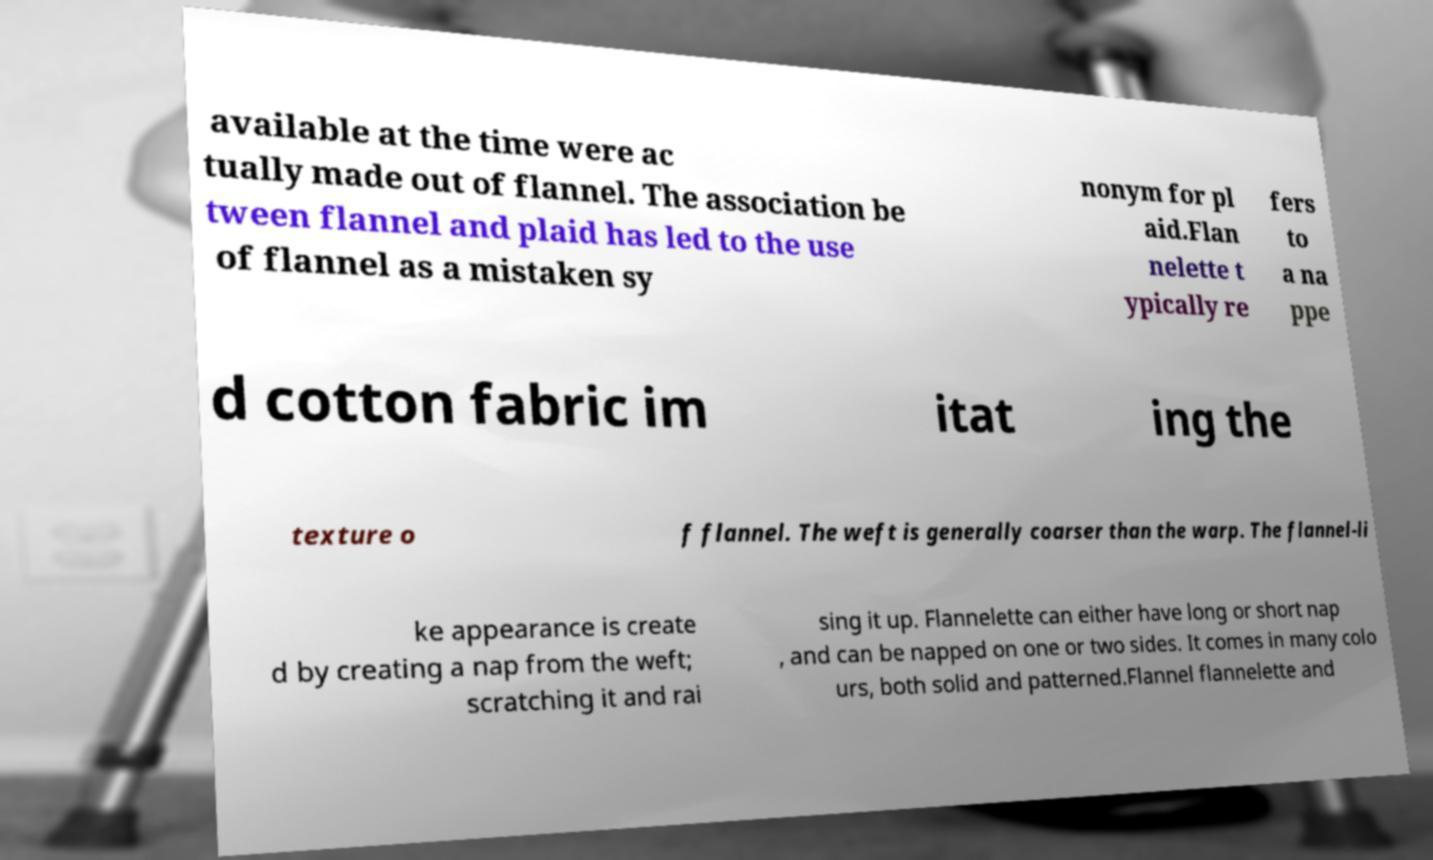What messages or text are displayed in this image? I need them in a readable, typed format. available at the time were ac tually made out of flannel. The association be tween flannel and plaid has led to the use of flannel as a mistaken sy nonym for pl aid.Flan nelette t ypically re fers to a na ppe d cotton fabric im itat ing the texture o f flannel. The weft is generally coarser than the warp. The flannel-li ke appearance is create d by creating a nap from the weft; scratching it and rai sing it up. Flannelette can either have long or short nap , and can be napped on one or two sides. It comes in many colo urs, both solid and patterned.Flannel flannelette and 